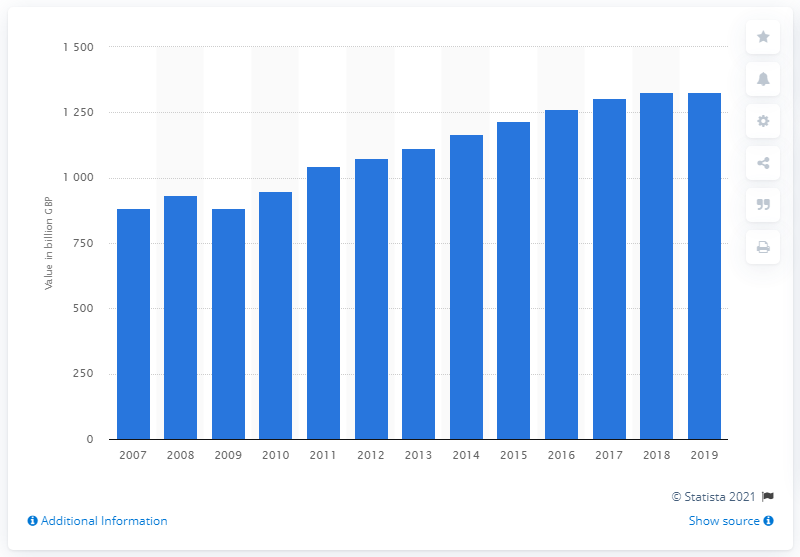Indicate a few pertinent items in this graphic. In 2019, the number of direct debit Bacs payments exceeded 40 billion. The total value of direct debit payments through Bacs from 2007 to 2018 was 1,326.77. 